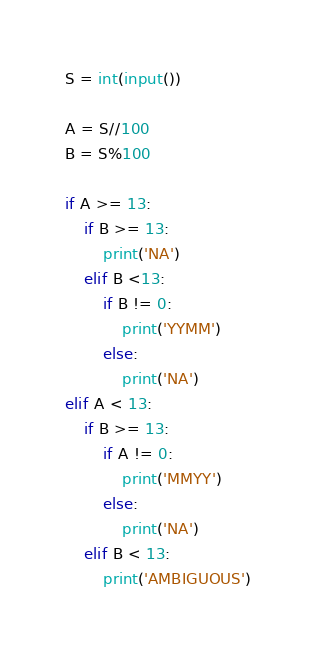<code> <loc_0><loc_0><loc_500><loc_500><_Python_>S = int(input())

A = S//100
B = S%100

if A >= 13:
    if B >= 13:
        print('NA')
    elif B <13:
        if B != 0:
            print('YYMM') 
        else:
            print('NA')
elif A < 13:
    if B >= 13:
        if A != 0:
            print('MMYY')
        else:
            print('NA')
    elif B < 13:
        print('AMBIGUOUS')
</code> 